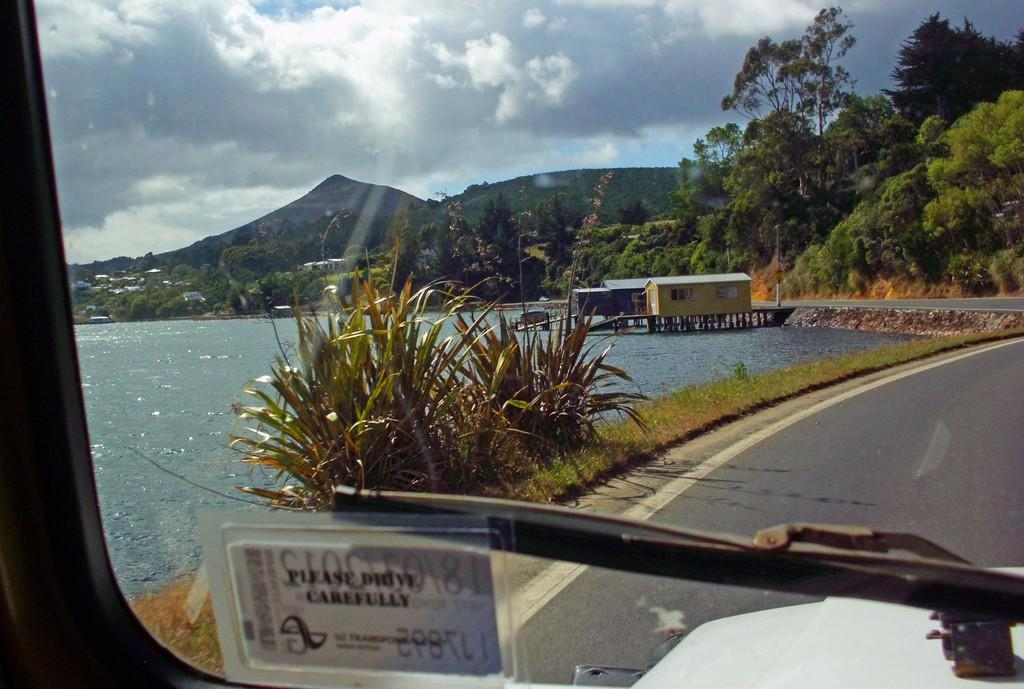What is the main subject of the image? The main subject of the image is a vehicle moving on a road. What type of natural environment is visible in the image? There are many trees, a water lake, and plant and grass visible in the image. How would you describe the weather in the image? The sky is sunny and cloudy in the image. What type of dinner is being served at the approval meeting in the image? There is no dinner or approval meeting present in the image; it features a vehicle moving on a road in a natural environment. 